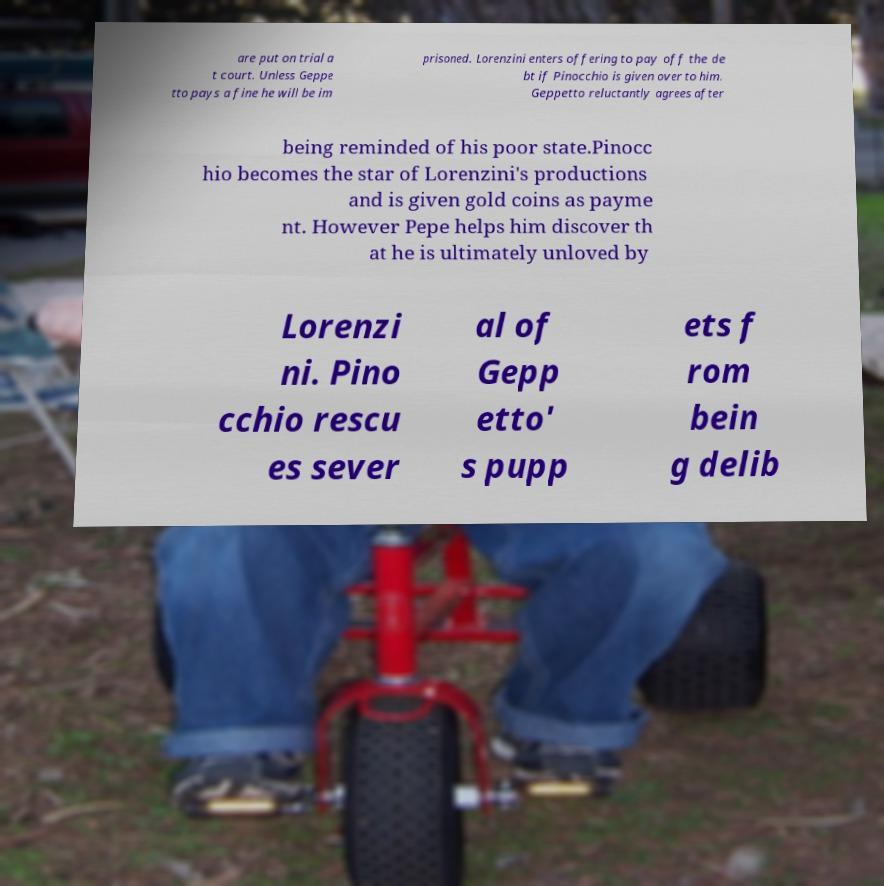Could you assist in decoding the text presented in this image and type it out clearly? are put on trial a t court. Unless Geppe tto pays a fine he will be im prisoned. Lorenzini enters offering to pay off the de bt if Pinocchio is given over to him. Geppetto reluctantly agrees after being reminded of his poor state.Pinocc hio becomes the star of Lorenzini's productions and is given gold coins as payme nt. However Pepe helps him discover th at he is ultimately unloved by Lorenzi ni. Pino cchio rescu es sever al of Gepp etto' s pupp ets f rom bein g delib 